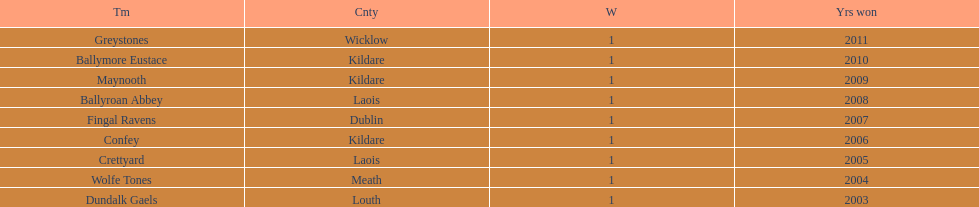What is the difference years won for crettyard and greystones 6. 